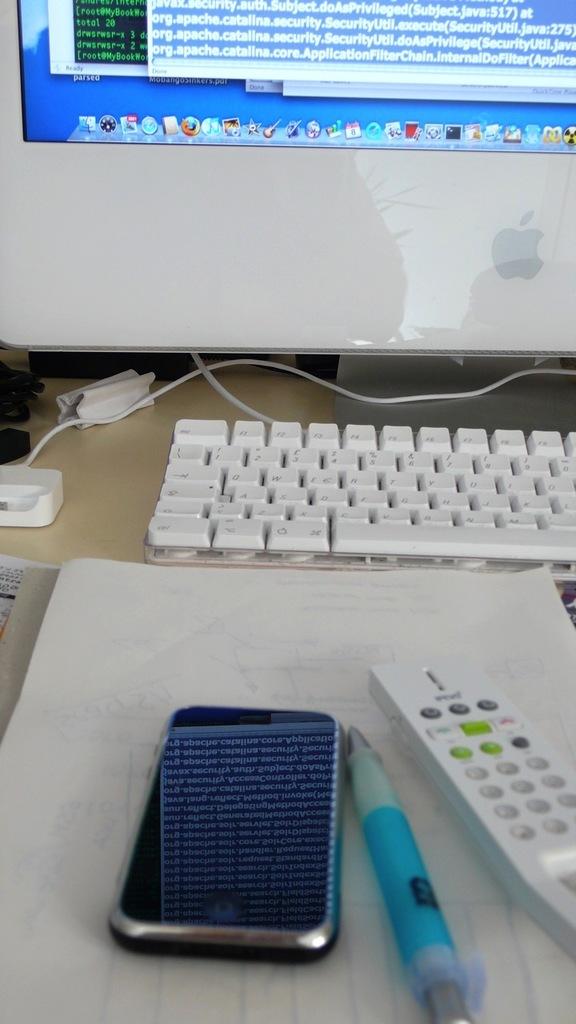What type of phone is that?
Make the answer very short. Answering does not require reading text in the image. 